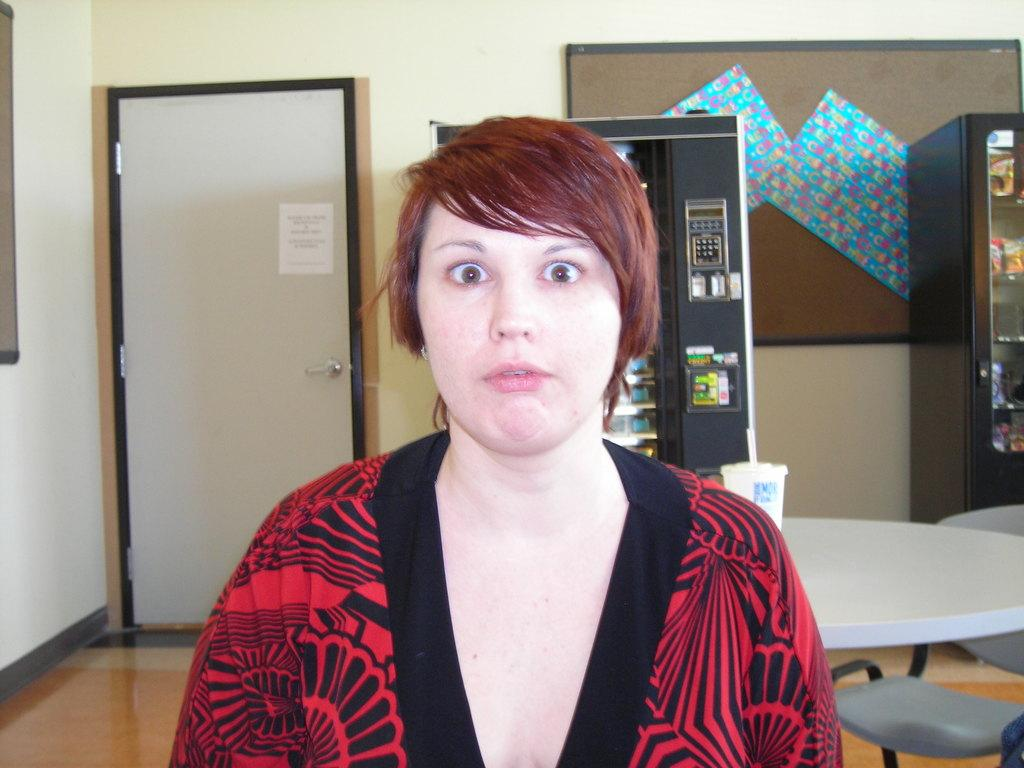Who is present in the image? There is a woman in the image. What objects can be seen in the background? There are two vending machines in the image. What is on the table in the image? There is a cup on a table in the image. What type of furniture is visible in the image? There are chairs in the image. What type of berry is growing on the road in the image? There is no road or berry present in the image. 